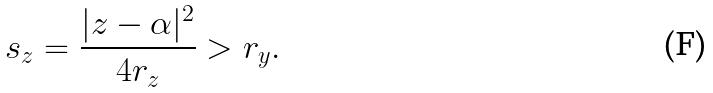Convert formula to latex. <formula><loc_0><loc_0><loc_500><loc_500>s _ { z } = \frac { | z - \alpha | ^ { 2 } } { 4 r _ { z } } > r _ { y } .</formula> 